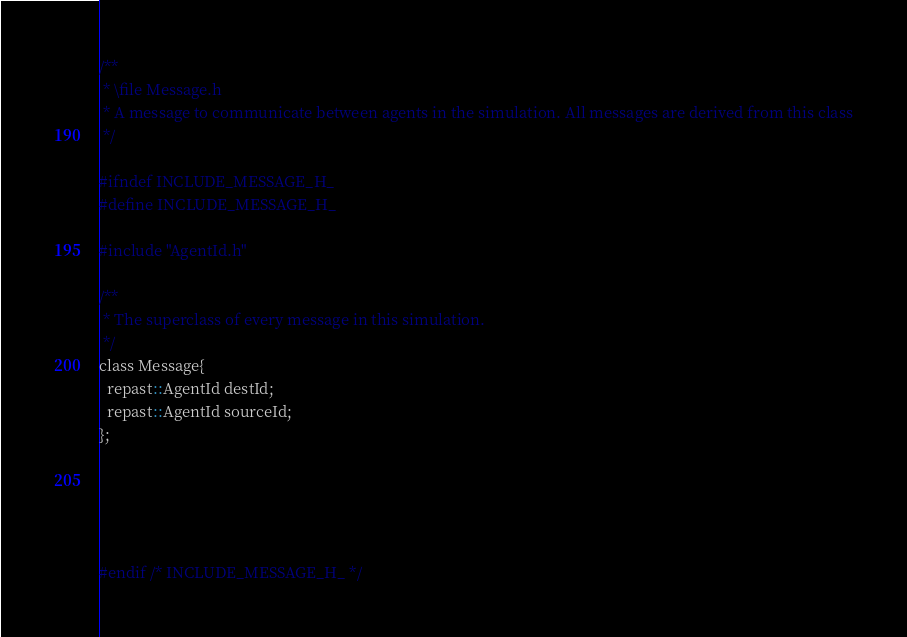<code> <loc_0><loc_0><loc_500><loc_500><_C_>/**
 * \file Message.h
 * A message to communicate between agents in the simulation. All messages are derived from this class
 */

#ifndef INCLUDE_MESSAGE_H_
#define INCLUDE_MESSAGE_H_

#include "AgentId.h"

/**
 * The superclass of every message in this simulation.
 */
class Message{
  repast::AgentId destId;
  repast::AgentId sourceId;
};





#endif /* INCLUDE_MESSAGE_H_ */
</code> 